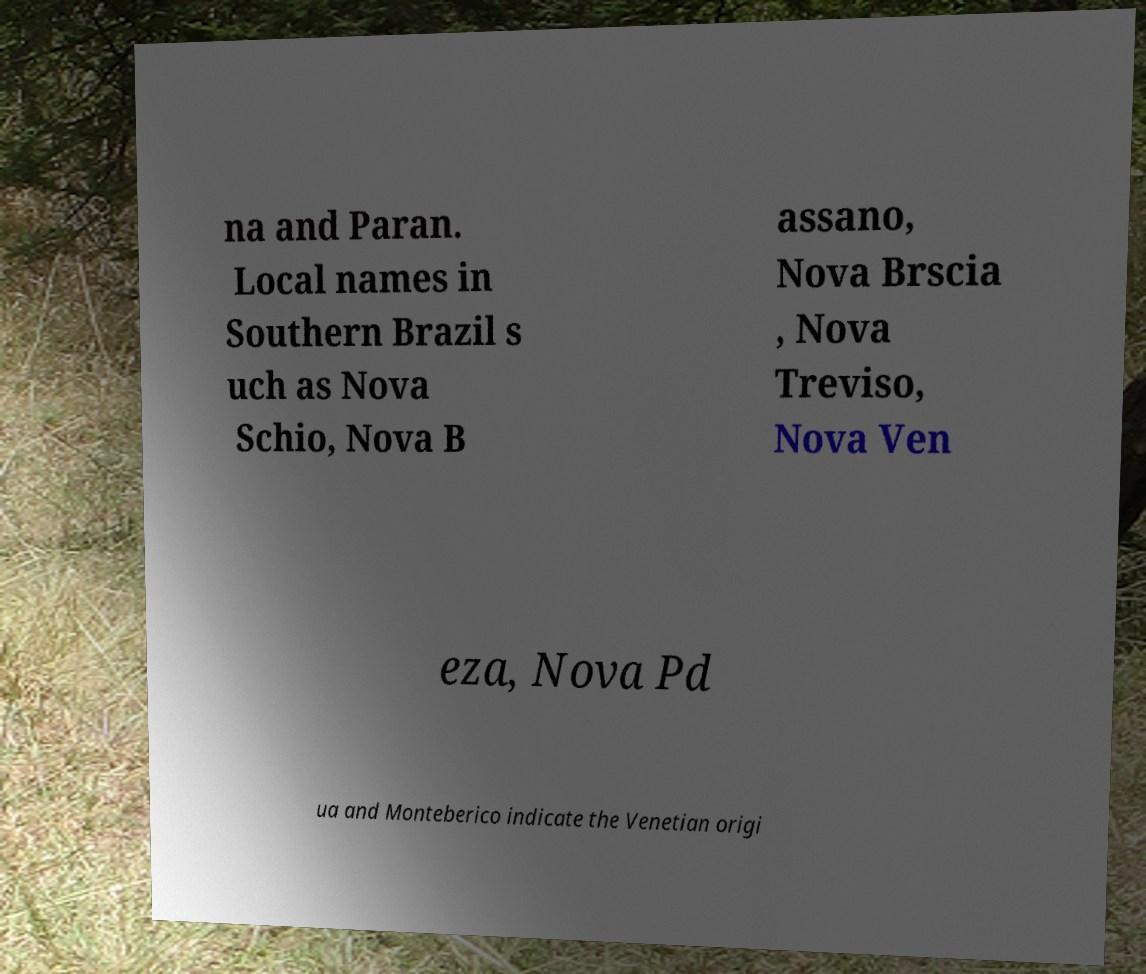What messages or text are displayed in this image? I need them in a readable, typed format. na and Paran. Local names in Southern Brazil s uch as Nova Schio, Nova B assano, Nova Brscia , Nova Treviso, Nova Ven eza, Nova Pd ua and Monteberico indicate the Venetian origi 